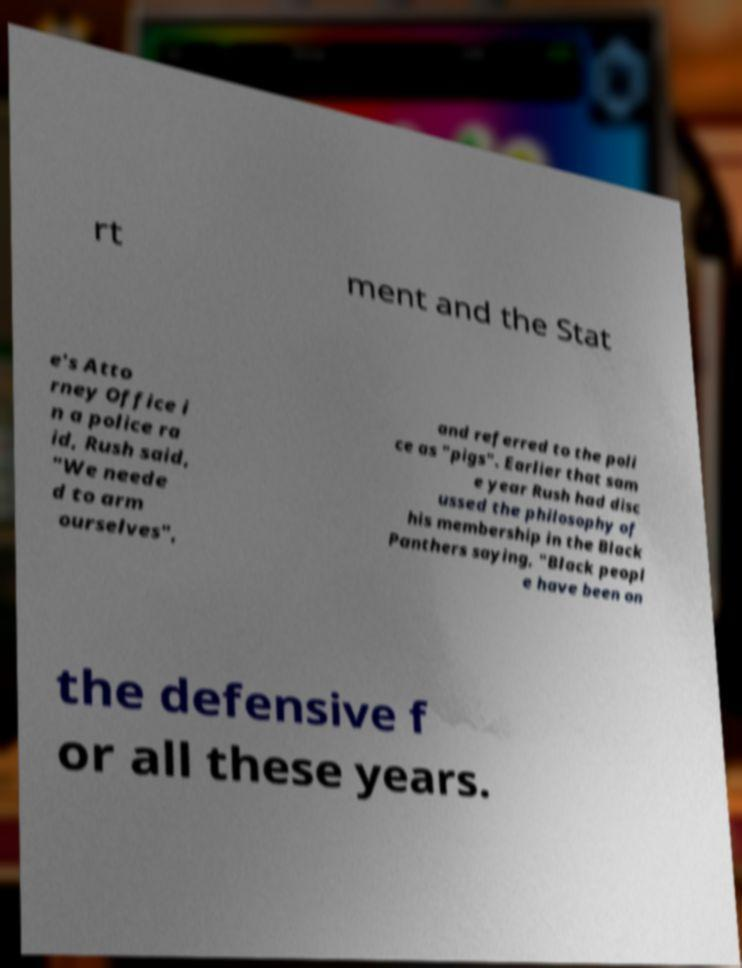Please identify and transcribe the text found in this image. rt ment and the Stat e's Atto rney Office i n a police ra id, Rush said, "We neede d to arm ourselves", and referred to the poli ce as "pigs". Earlier that sam e year Rush had disc ussed the philosophy of his membership in the Black Panthers saying, "Black peopl e have been on the defensive f or all these years. 